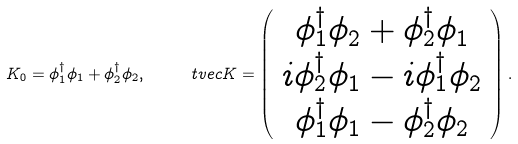Convert formula to latex. <formula><loc_0><loc_0><loc_500><loc_500>K _ { 0 } = \phi _ { 1 } ^ { \dagger } \phi _ { 1 } + \phi _ { 2 } ^ { \dagger } \phi _ { 2 } , \quad \ t v e c { K } = \left ( \begin{array} { c } \phi _ { 1 } ^ { \dagger } \phi _ { 2 } + \phi _ { 2 } ^ { \dagger } \phi _ { 1 } \\ i \phi _ { 2 } ^ { \dagger } \phi _ { 1 } - i \phi _ { 1 } ^ { \dagger } \phi _ { 2 } \\ \phi _ { 1 } ^ { \dagger } \phi _ { 1 } - \phi _ { 2 } ^ { \dagger } \phi _ { 2 } \end{array} \right ) .</formula> 